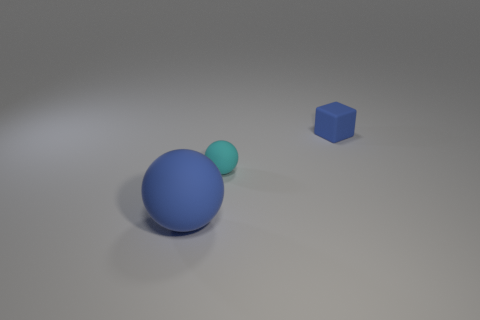Subtract all blue spheres. How many spheres are left? 1 Add 2 small cyan matte balls. How many objects exist? 5 Add 2 small cyan objects. How many small cyan objects are left? 3 Add 2 tiny balls. How many tiny balls exist? 3 Subtract 0 brown blocks. How many objects are left? 3 Subtract all spheres. How many objects are left? 1 Subtract 1 blocks. How many blocks are left? 0 Subtract all green blocks. Subtract all blue balls. How many blocks are left? 1 Subtract all green cubes. How many blue balls are left? 1 Subtract all blue rubber cubes. Subtract all tiny rubber objects. How many objects are left? 0 